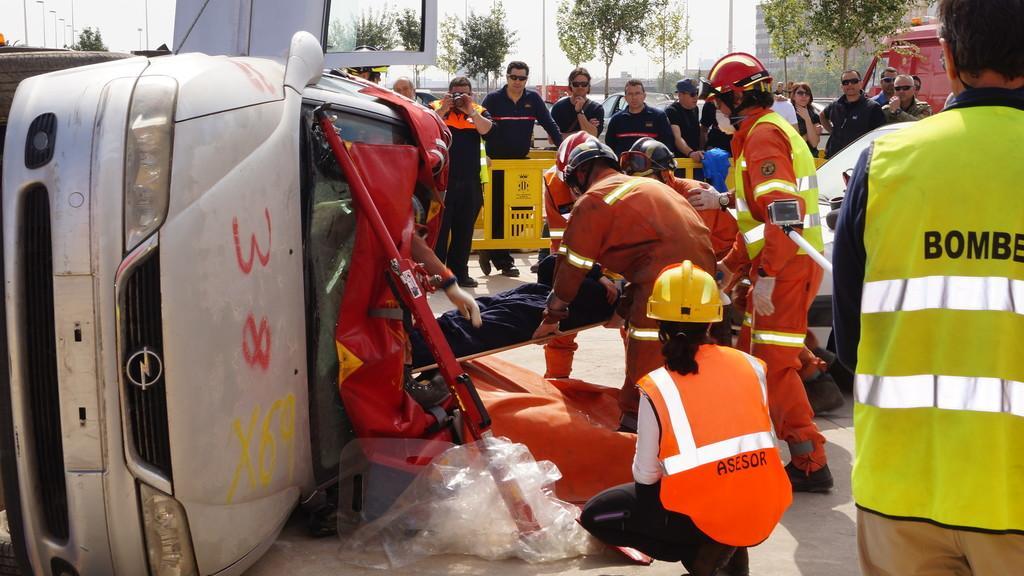In one or two sentences, can you explain what this image depicts? On the right side of the image we can see person standing and vehicle. On the left side of the image we can see car and street lights. In the center of the image we can see persons rescuing a man. In the background we can see trees, pole, buildings and sky. 